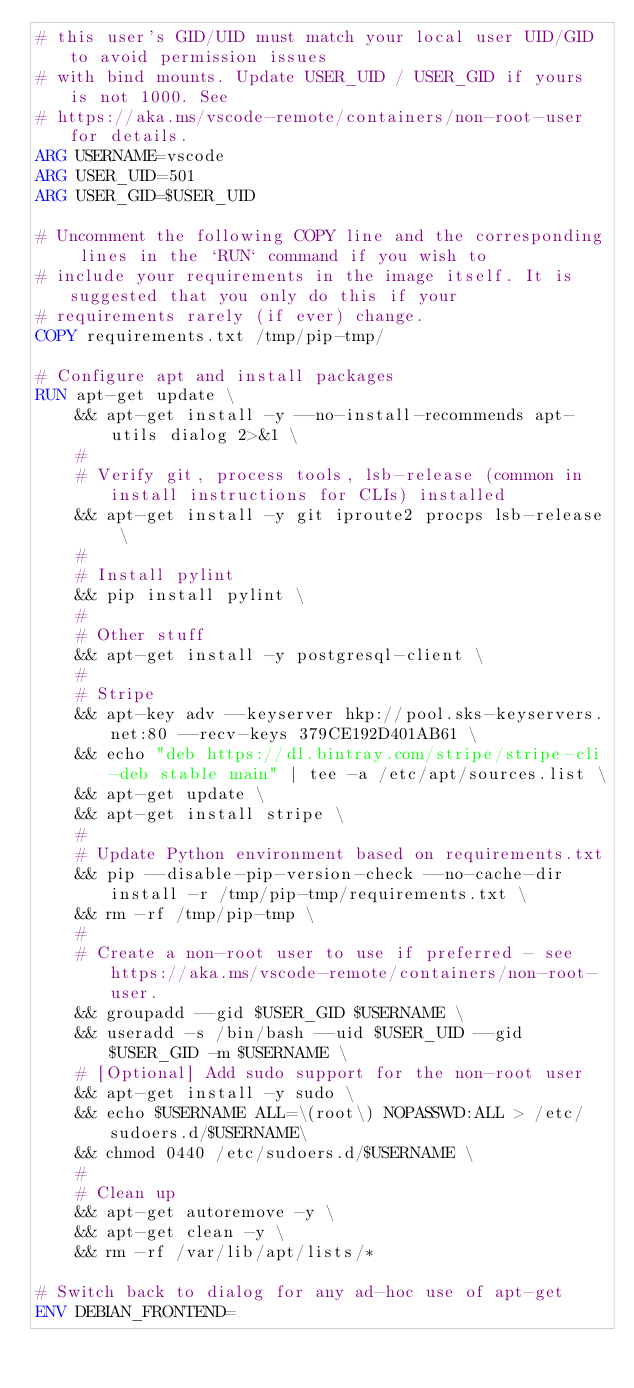<code> <loc_0><loc_0><loc_500><loc_500><_Dockerfile_># this user's GID/UID must match your local user UID/GID to avoid permission issues
# with bind mounts. Update USER_UID / USER_GID if yours is not 1000. See
# https://aka.ms/vscode-remote/containers/non-root-user for details.
ARG USERNAME=vscode
ARG USER_UID=501
ARG USER_GID=$USER_UID

# Uncomment the following COPY line and the corresponding lines in the `RUN` command if you wish to
# include your requirements in the image itself. It is suggested that you only do this if your
# requirements rarely (if ever) change.
COPY requirements.txt /tmp/pip-tmp/

# Configure apt and install packages
RUN apt-get update \
    && apt-get install -y --no-install-recommends apt-utils dialog 2>&1 \
    #
    # Verify git, process tools, lsb-release (common in install instructions for CLIs) installed
    && apt-get install -y git iproute2 procps lsb-release \
    #
    # Install pylint
    && pip install pylint \
    #
    # Other stuff
    && apt-get install -y postgresql-client \
    #
    # Stripe
    && apt-key adv --keyserver hkp://pool.sks-keyservers.net:80 --recv-keys 379CE192D401AB61 \
    && echo "deb https://dl.bintray.com/stripe/stripe-cli-deb stable main" | tee -a /etc/apt/sources.list \
    && apt-get update \
    && apt-get install stripe \
    #
    # Update Python environment based on requirements.txt
    && pip --disable-pip-version-check --no-cache-dir install -r /tmp/pip-tmp/requirements.txt \
    && rm -rf /tmp/pip-tmp \
    #
    # Create a non-root user to use if preferred - see https://aka.ms/vscode-remote/containers/non-root-user.
    && groupadd --gid $USER_GID $USERNAME \
    && useradd -s /bin/bash --uid $USER_UID --gid $USER_GID -m $USERNAME \
    # [Optional] Add sudo support for the non-root user
    && apt-get install -y sudo \
    && echo $USERNAME ALL=\(root\) NOPASSWD:ALL > /etc/sudoers.d/$USERNAME\
    && chmod 0440 /etc/sudoers.d/$USERNAME \
    #
    # Clean up
    && apt-get autoremove -y \
    && apt-get clean -y \
    && rm -rf /var/lib/apt/lists/*

# Switch back to dialog for any ad-hoc use of apt-get
ENV DEBIAN_FRONTEND=
</code> 